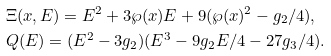<formula> <loc_0><loc_0><loc_500><loc_500>& \Xi ( x , E ) = E ^ { 2 } + 3 \wp ( x ) E + 9 ( \wp ( x ) ^ { 2 } - g _ { 2 } / 4 ) , \\ & Q ( E ) = ( E ^ { 2 } - 3 g _ { 2 } ) ( E ^ { 3 } - 9 g _ { 2 } E / 4 - 2 7 g _ { 3 } / 4 ) .</formula> 